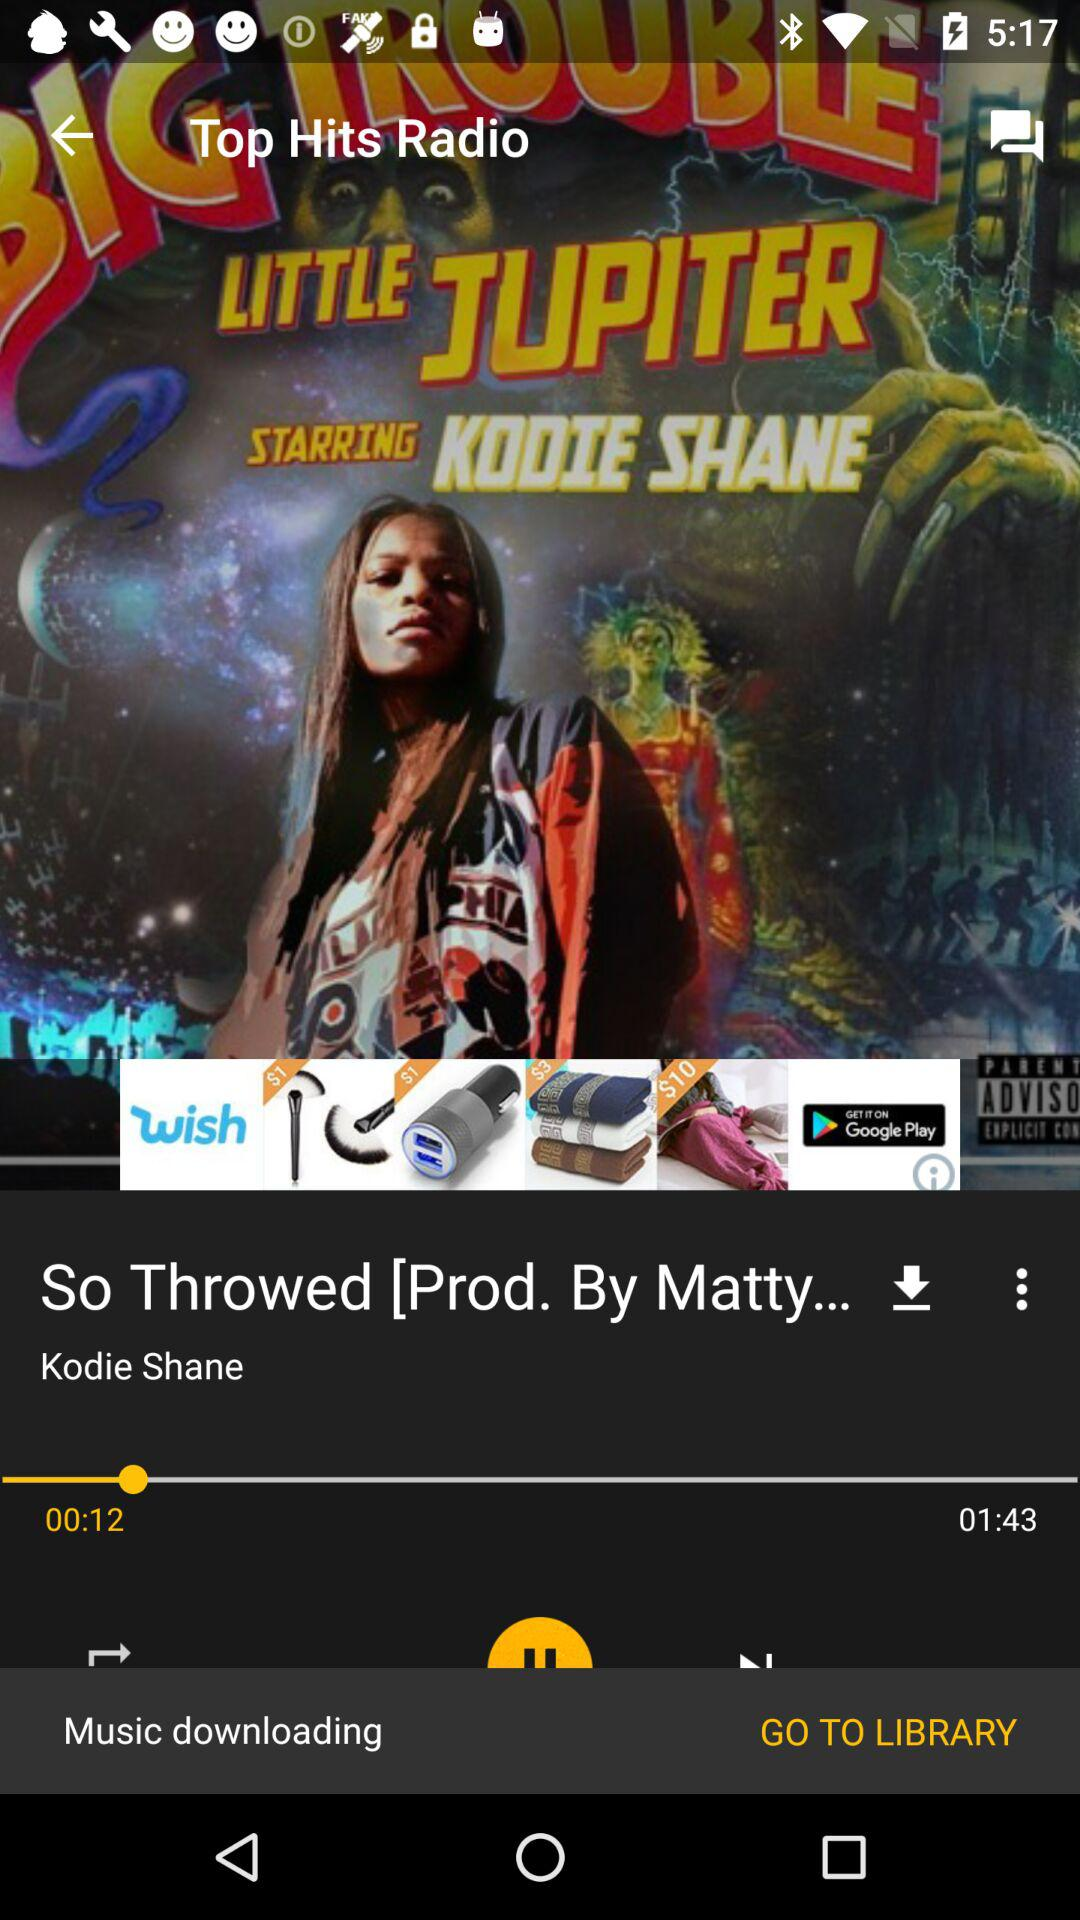What is the name of the song? The name of the song is "So Throwed". 